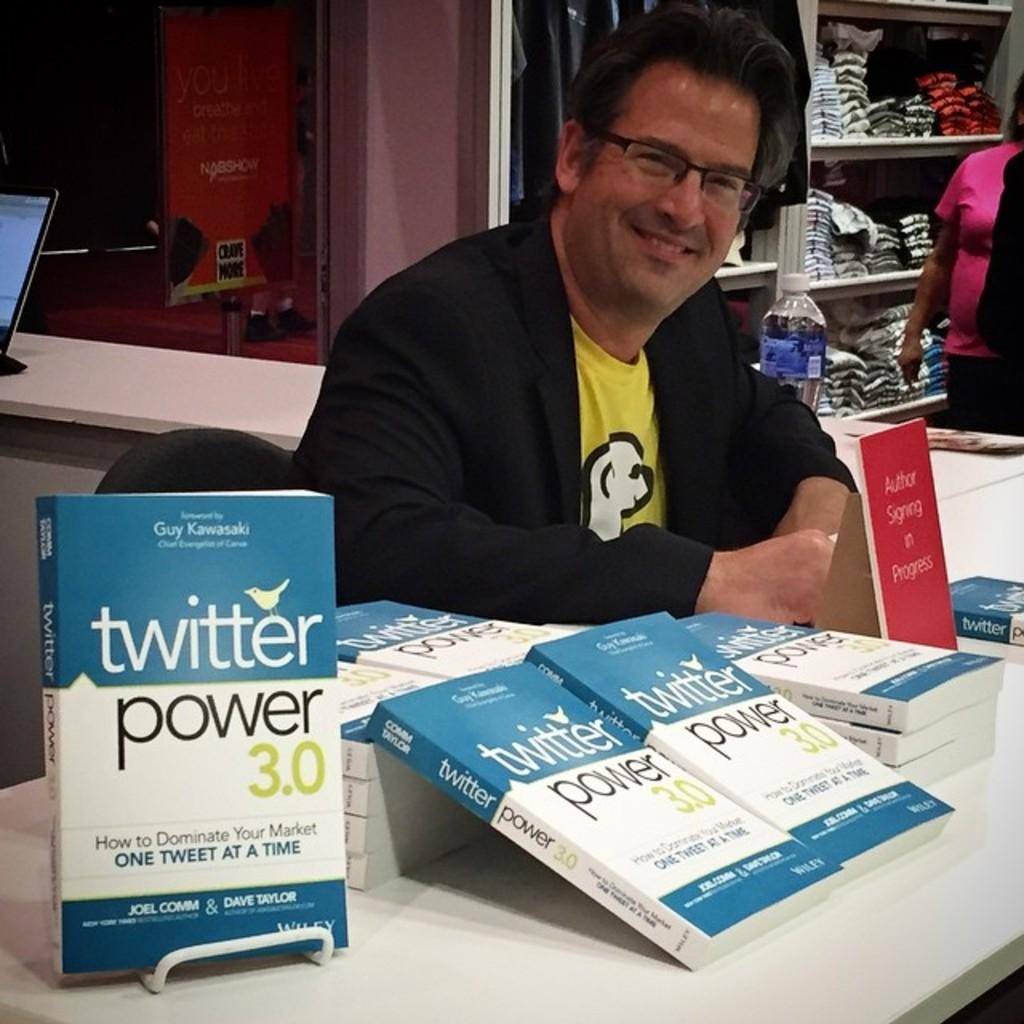<image>
Give a short and clear explanation of the subsequent image. The author of the book "Twitter Power 3.0" sign copies of his book at a table. 